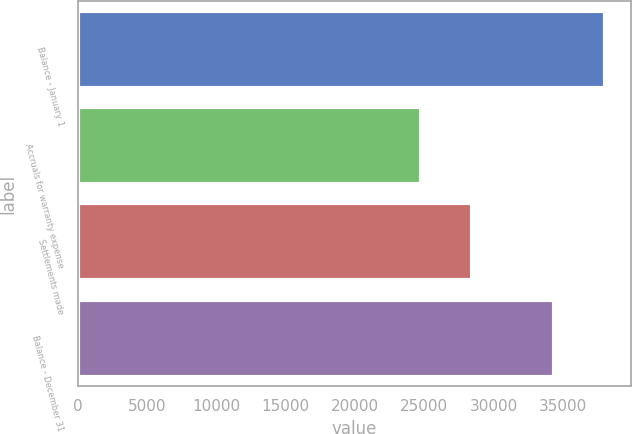<chart> <loc_0><loc_0><loc_500><loc_500><bar_chart><fcel>Balance - January 1<fcel>Accruals for warranty expense<fcel>Settlements made<fcel>Balance - December 31<nl><fcel>38024<fcel>24779<fcel>28429<fcel>34374<nl></chart> 